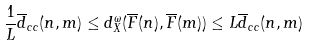<formula> <loc_0><loc_0><loc_500><loc_500>\frac { 1 } { L } \overline { d } _ { c c } ( n , m ) \leq d ^ { \omega } _ { X } ( \overline { F } ( n ) , \overline { F } ( m ) ) \leq L \overline { d } _ { c c } ( n , m )</formula> 